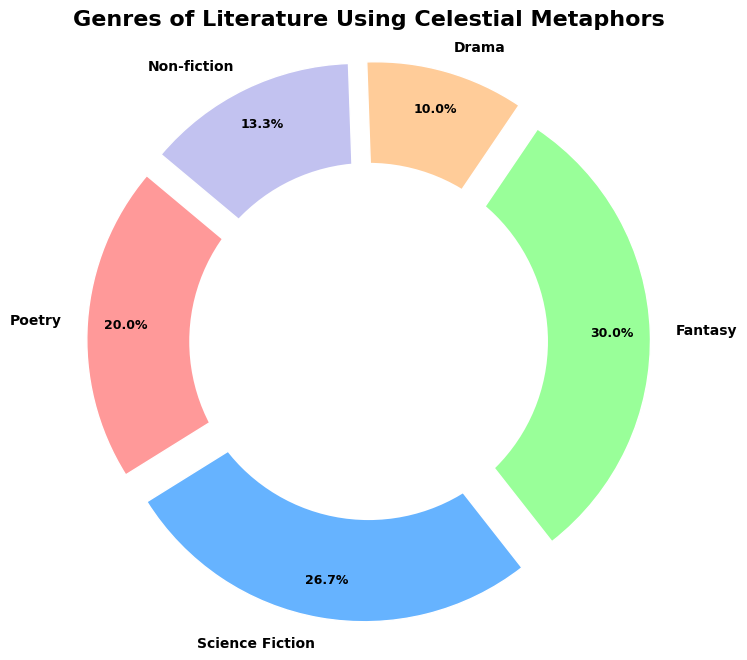Which genre uses celestial metaphors the most? By examining the percentages in the figure, the genre with the highest percentage is Fantasy.
Answer: Fantasy Which genre has the smallest use of celestial metaphors? The genre with the lowest percentage in the figure is Drama.
Answer: Drama How many more genres use celestial metaphors in Poetry compared to Non-fiction? Poetry has a percentage of 60/300 (20%), while Non-fiction has 40/300 (13.33%). The difference as per percentage points is 20% - 13.33% = 6.67%. To convert these percentage points back to the original frequencies:
(60 - 40) = 20 more genres.
Answer: 20 What is the combined percentage of Science Fiction and Poetry? Science Fiction is 26.7% and Poetry is 20%, so the combined percentage is 26.7% + 20% = 46.7%.
Answer: 46.7% Which genres together contribute to more than 50% of the celestial metaphors use? Fantasy (30%), Science Fiction (26.7%), and Poetry (20%). Together, they sum to 76.7%, which is more than 50%.
Answer: Fantasy, Science Fiction, and Poetry How many genres use celestial metaphors more than Drama but less than Fantasy? Drama is at 10%, and Fantasy is at 30%. The genres in this range are Poetry (20%), Science Fiction (26.7%), and Non-fiction (13.3%). So, there are 3 genres.
Answer: 3 Which genre's representation is closest to one-quarter of the total celestial metaphor use in literature? 25% of the total would be represented by a genre that has around 75 mentions. Science Fiction, with 26.7%, is closest to this.
Answer: Science Fiction Is the use of celestial metaphors in Non-fiction greater than in Drama? Non-fiction has 13.3%, while Drama has 10%. So, yes, Non-fiction uses celestial metaphors more than Drama.
Answer: Yes 